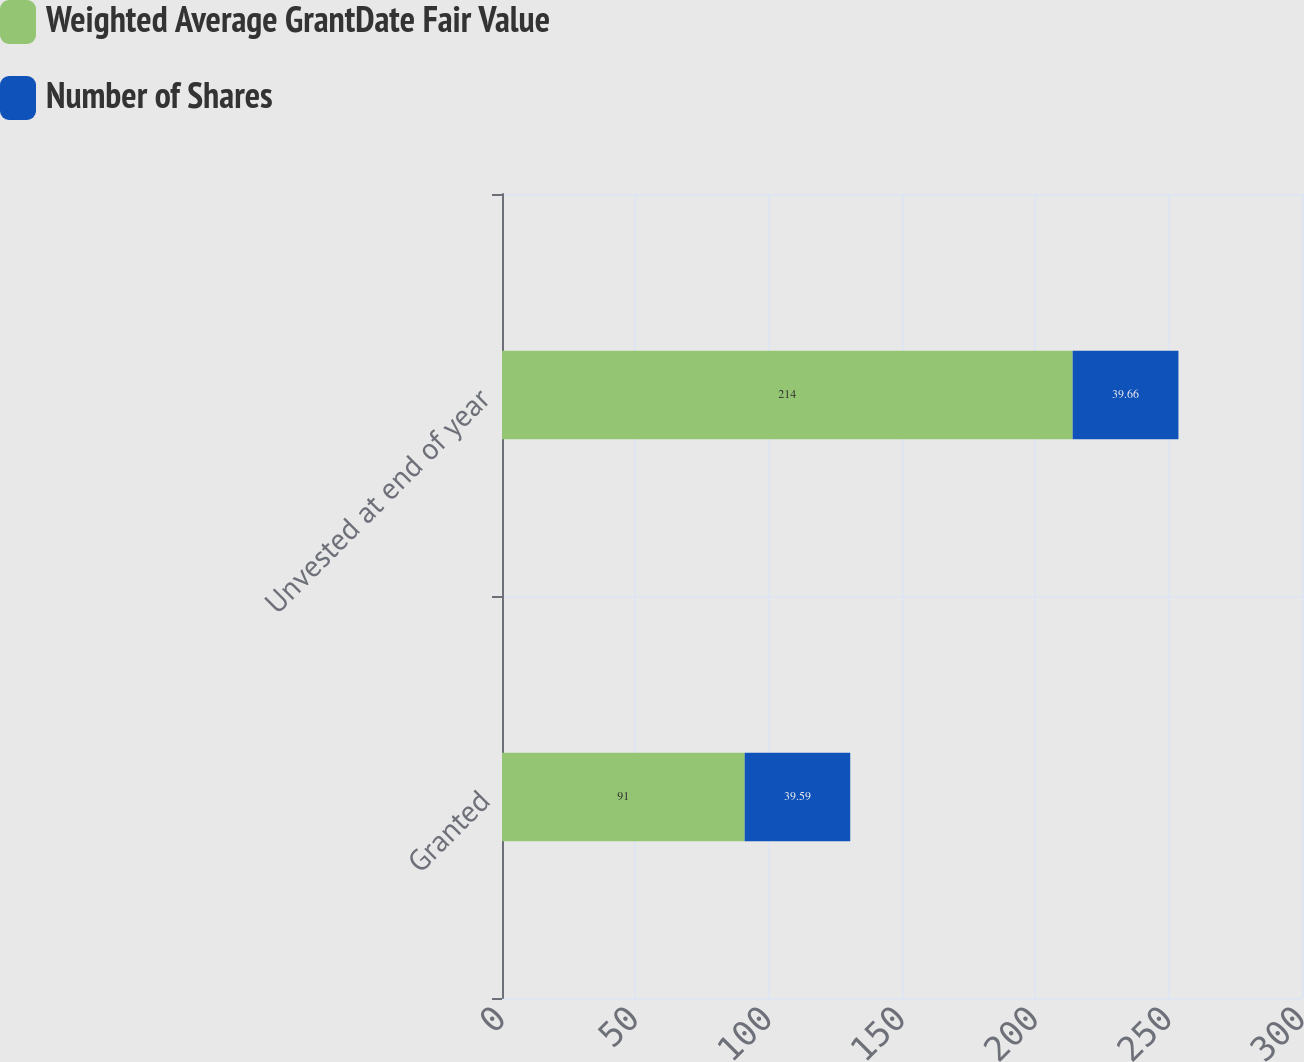Convert chart. <chart><loc_0><loc_0><loc_500><loc_500><stacked_bar_chart><ecel><fcel>Granted<fcel>Unvested at end of year<nl><fcel>Weighted Average GrantDate Fair Value<fcel>91<fcel>214<nl><fcel>Number of Shares<fcel>39.59<fcel>39.66<nl></chart> 